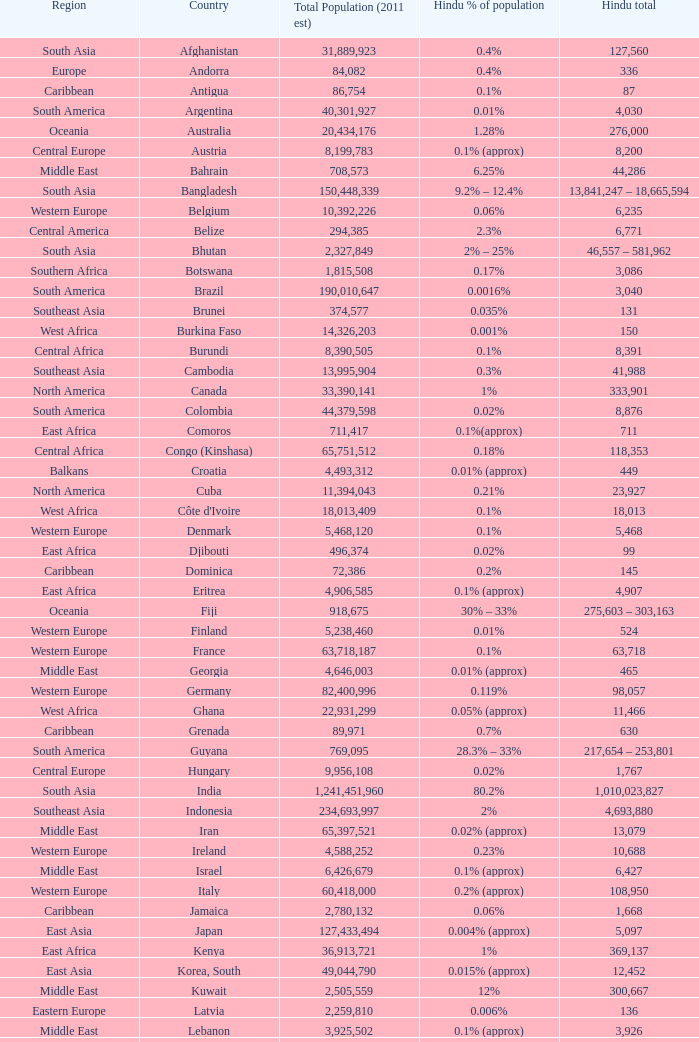In which country is the total population (2011 est) more than 30,262,610, with a hindu figure of 63,718? France. 